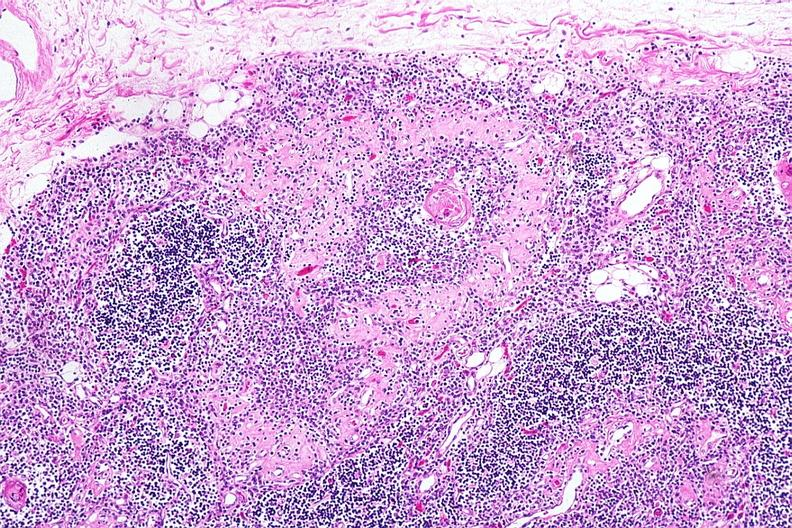does this image show hassalls corpuscle with fibrosis in periphery of surrounding lymphoid follicle lesion?
Answer the question using a single word or phrase. Yes 